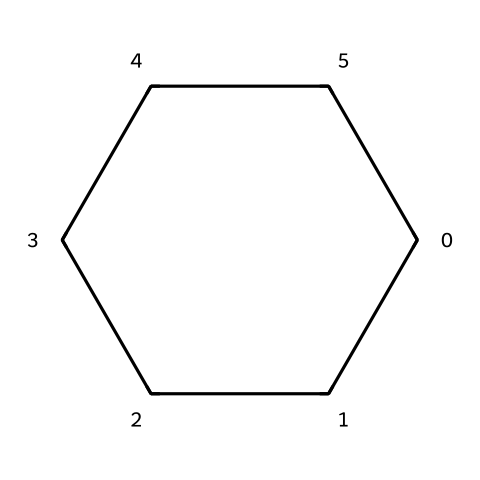What is the molecular formula of this compound? The compound consists of six carbon atoms and twelve hydrogen atoms, which can be determined by looking at the structure that represents cyclohexane. Each corner of the ring represents a carbon atom, and each carbon is bonded to enough hydrogen atoms to satisfy the tetravalency of carbon. Therefore, the molecular formula is C6H12.
Answer: C6H12 How many carbon atoms are present in the structure? By analyzing the SMILES notation C1CCCCC1, it is clear that it indicates six carbon atoms arranged in a ring. Each occurrence of "C" corresponds to one carbon atom. Thus, there are six carbon atoms total.
Answer: 6 What is the degree of unsaturation in cyclohexane? The degree of unsaturation can be calculated using the formula: (2C + 2 + N - H - X)/2. For cyclohexane (C6H12), we have six carbons (C) and twelve hydrogens (H), but no nitrogens (N) or halogens (X). Plugging these values into the formula gives (2(6) + 2 - 12)/2 = 0. Thus, the degree of unsaturation is zero, indicating it is fully saturated.
Answer: 0 What type of bonding is primarily present in cyclohexane? The primary type of bonding in cyclohexane is single covalent bonding. Each carbon atom is bonded to two other carbon atoms and two hydrogen atoms, forming only single bonds throughout the structure without any double or triple bonds.
Answer: single covalent Is cyclohexane a polar or nonpolar solvent? Cyclohexane is categorized as a nonpolar solvent due to its symmetric molecular structure and lack of significant electronegative differences between the bonded atoms. The distribution of charge is even, leading to a nonpolar character.
Answer: nonpolar What is the typical use of cyclohexane in laboratories? Cyclohexane is commonly used as a solvent in laboratories, particularly for dissolving nonpolar compounds and in reactions that require an inert environment. Its properties make it suitable for various types of chemical analyses and experiments.
Answer: solvent What is the shape of cyclohexane's molecular structure? Cyclohexane adopts a chair conformation, which is the most stable arrangement for minimizing steric strain and torsional strain in the cyclic structure. This three-dimensional arrangement allows for optimal bonding and spatial distribution of hydrogen atoms.
Answer: chair 